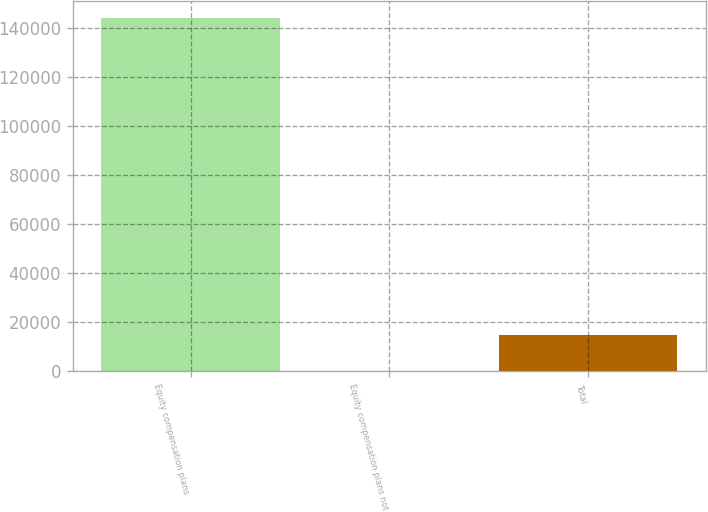Convert chart. <chart><loc_0><loc_0><loc_500><loc_500><bar_chart><fcel>Equity compensation plans<fcel>Equity compensation plans not<fcel>Total<nl><fcel>143802<fcel>217<fcel>14597<nl></chart> 